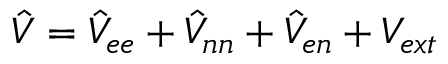Convert formula to latex. <formula><loc_0><loc_0><loc_500><loc_500>\hat { V } = \hat { V } _ { e e } + \hat { V } _ { n n } + \hat { V } _ { e n } + V _ { e x t }</formula> 